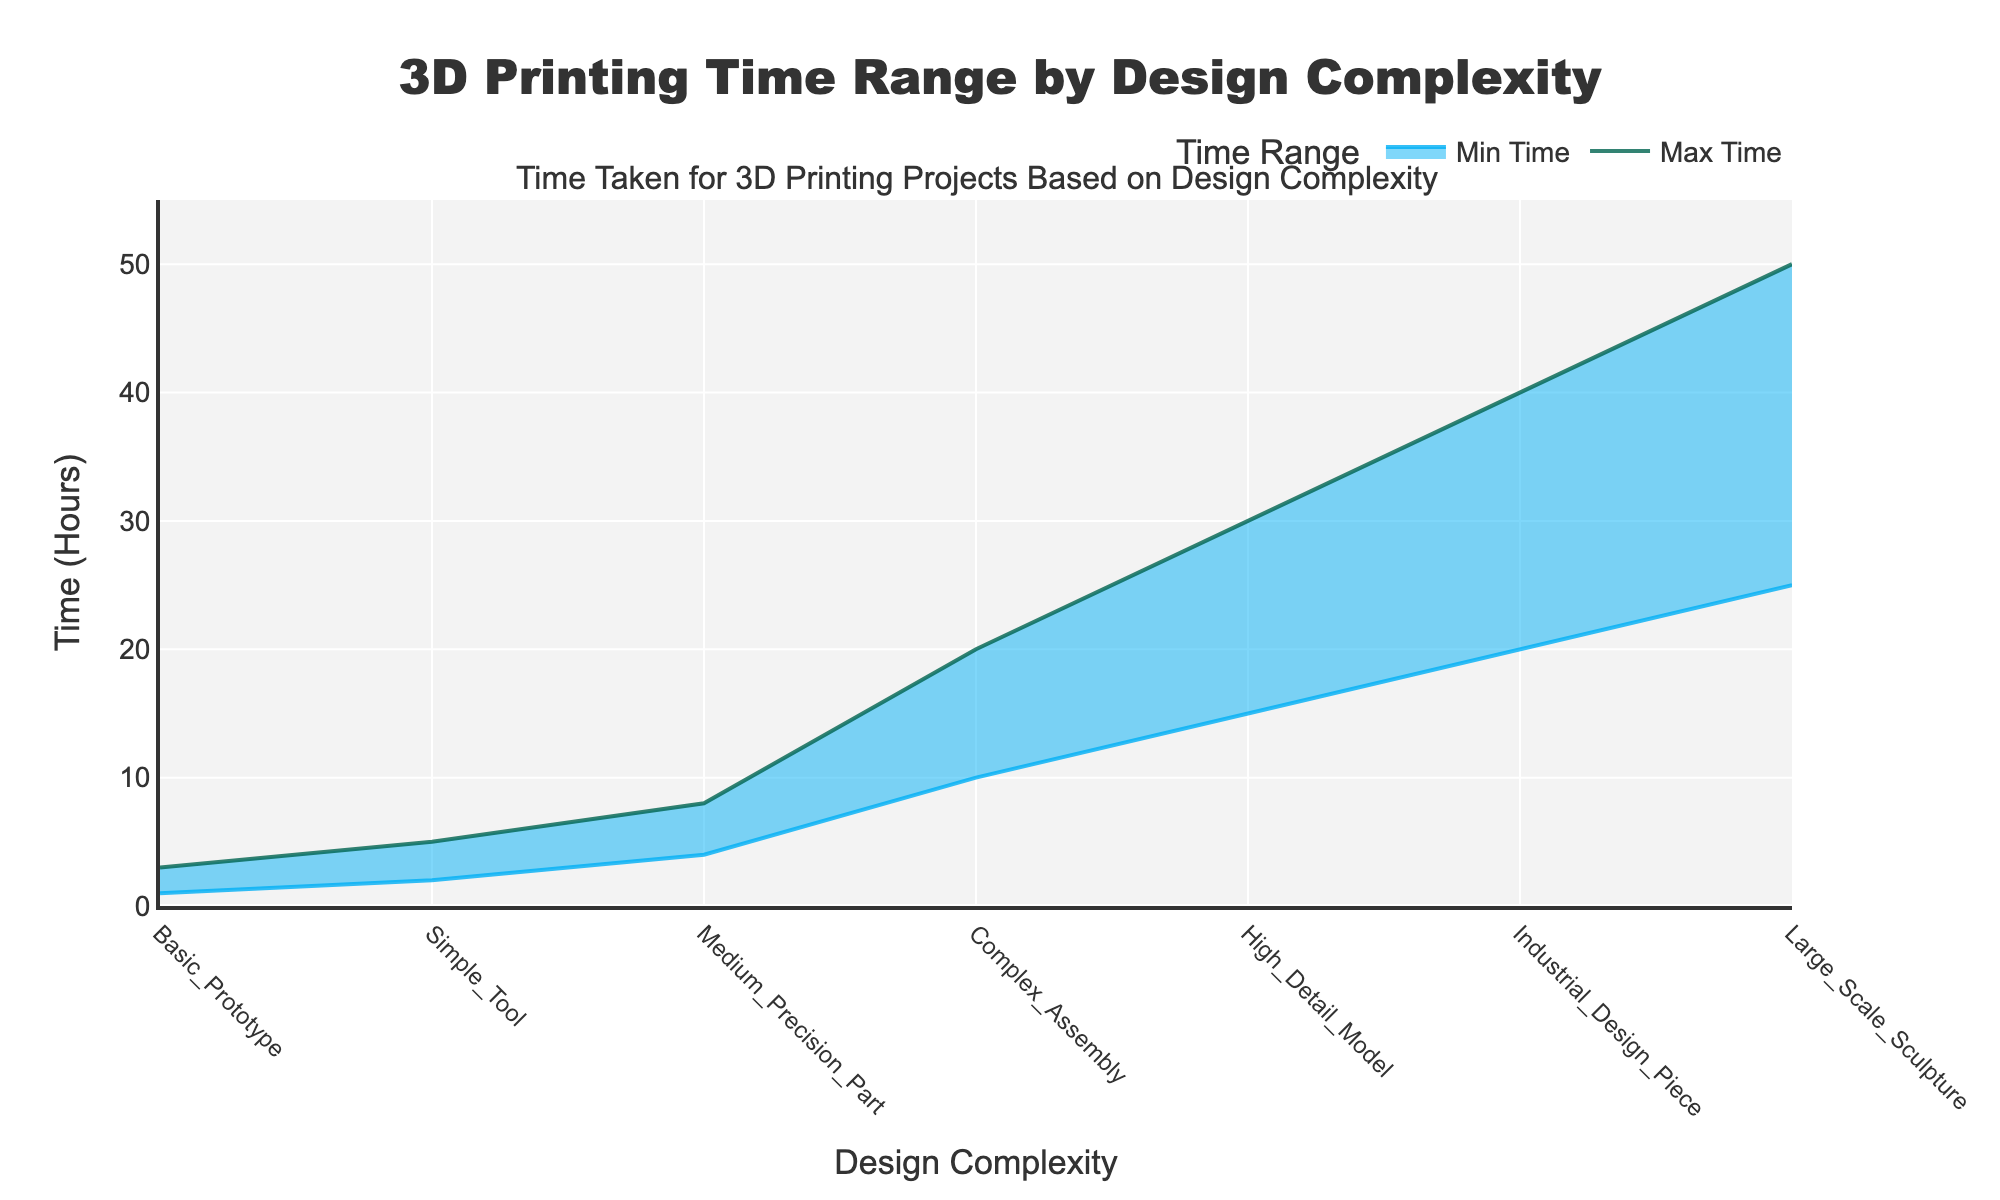What is the title of the figure? The title is typically placed at the top of the chart and provides a summary of what the chart is about.
Answer: 3D Printing Time Range by Design Complexity How many different design complexities are included in this figure? By counting the number of categories on the x-axis, we can determine the number of different design complexities represented.
Answer: 7 What is the color used to represent the maximum time taken? By visually inspecting the lines at the top of the shaded areas, we can identify the color representing the maximum time.
Answer: Dark green Which design complexity has the widest range of time taken? The width of the range is the difference between the max and min times. By visually comparing all ranges, we see which one has the largest difference.
Answer: Large Scale Sculpture What is the minimum time taken for a Complex Assembly? Locate "Complex Assembly" on the x-axis and refer to the corresponding value on the y-axis filled with light blue color.
Answer: 10 hours By how many hours does the minimum printing time for a Simple Tool exceed that for a Basic Prototype? Subtract the minimum time for Basic Prototype from the minimum time for Simple Tool (2 hours - 1 hour).
Answer: 1 hour What is the average maximum time taken for High Detail Model and Industrial Design Piece? Add the max times for both categories (30 + 40) and divide by 2 to find the average.
Answer: 35 hours Which design complexity has both the lowest minimum and maximum time? Compare all minimum and maximum times to identify the design complexity with the smallest values.
Answer: Basic Prototype Which design complexity takes at least 15 hours for both its minimum and maximum times? Identify the design complexity categories and check if both their minimum and maximum times are at least 15 hours.
Answer: High Detail Model Does the time range for Medium Precision Part overlap with that for Complex Assembly? Check whether the maximum time for Medium Precision Part (8 hours) is higher than or equal to the minimum time for Complex Assembly (10 hours).
Answer: No 